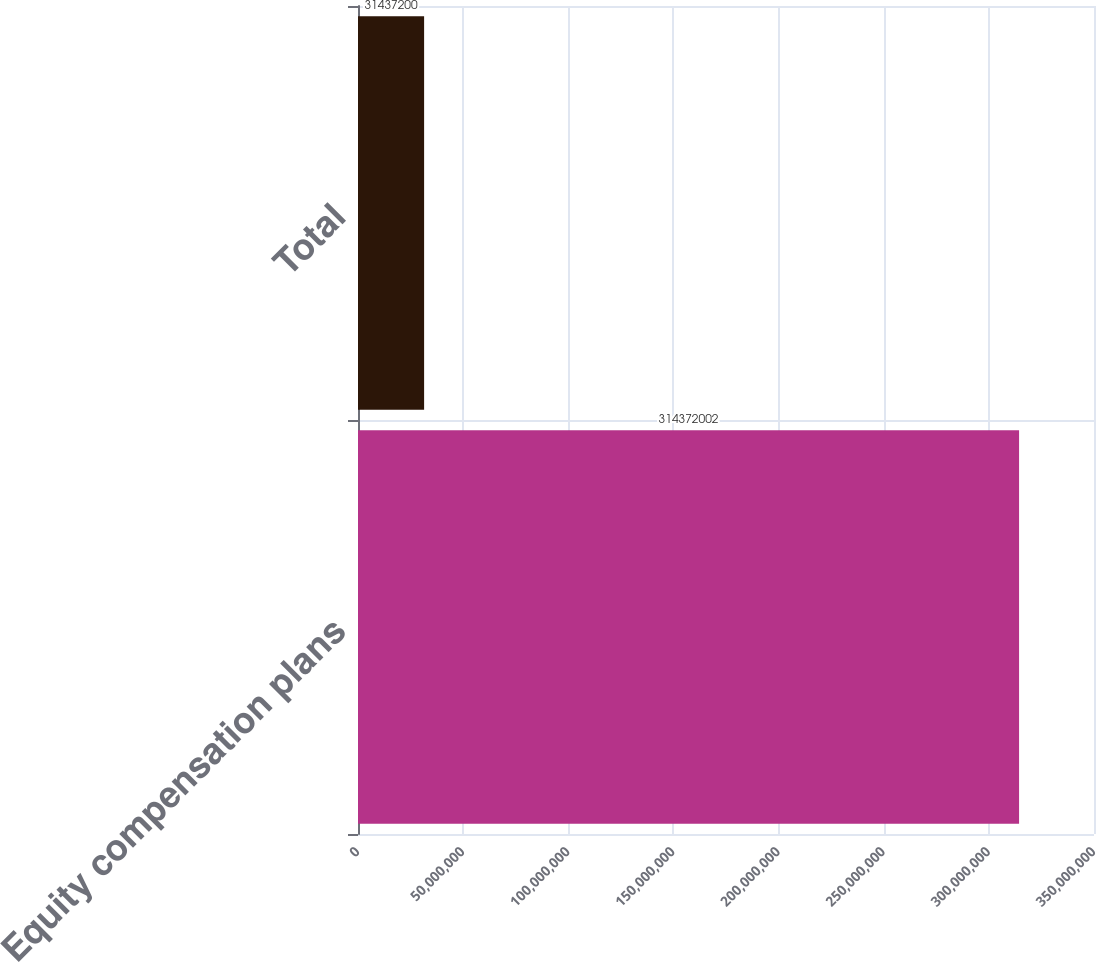Convert chart. <chart><loc_0><loc_0><loc_500><loc_500><bar_chart><fcel>Equity compensation plans<fcel>Total<nl><fcel>3.14372e+08<fcel>3.14372e+07<nl></chart> 